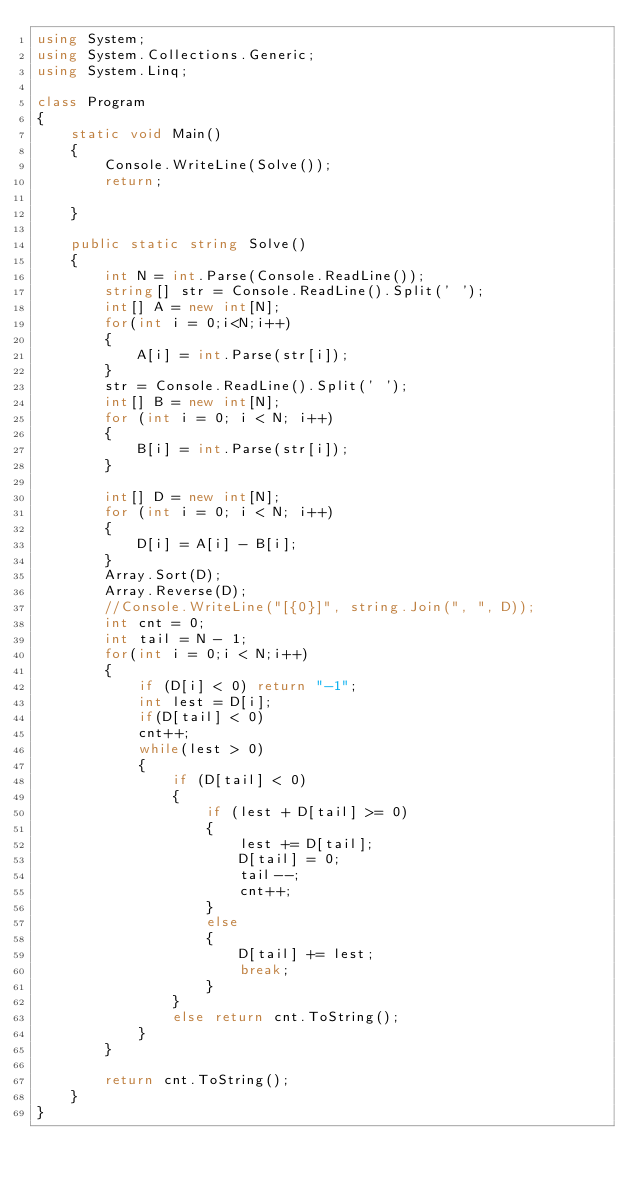Convert code to text. <code><loc_0><loc_0><loc_500><loc_500><_C#_>using System;
using System.Collections.Generic;
using System.Linq;

class Program
{
    static void Main()
    {
        Console.WriteLine(Solve());
        return;

    }

    public static string Solve()
    {
        int N = int.Parse(Console.ReadLine());
        string[] str = Console.ReadLine().Split(' ');
        int[] A = new int[N];
        for(int i = 0;i<N;i++)
        {
            A[i] = int.Parse(str[i]);
        }
        str = Console.ReadLine().Split(' ');
        int[] B = new int[N];
        for (int i = 0; i < N; i++)
        {
            B[i] = int.Parse(str[i]);
        }

        int[] D = new int[N];
        for (int i = 0; i < N; i++)
        {
            D[i] = A[i] - B[i];
        }
        Array.Sort(D);
        Array.Reverse(D);
        //Console.WriteLine("[{0}]", string.Join(", ", D));
        int cnt = 0;
        int tail = N - 1;
        for(int i = 0;i < N;i++)
        {
            if (D[i] < 0) return "-1";
            int lest = D[i];
            if(D[tail] < 0)
            cnt++;
            while(lest > 0)
            {
                if (D[tail] < 0)
                {
                    if (lest + D[tail] >= 0)
                    {
                        lest += D[tail];
                        D[tail] = 0;
                        tail--;
                        cnt++;
                    }
                    else
                    {
                        D[tail] += lest;
                        break;
                    }
                }
                else return cnt.ToString();
            }
        }

        return cnt.ToString();
    }
}
</code> 